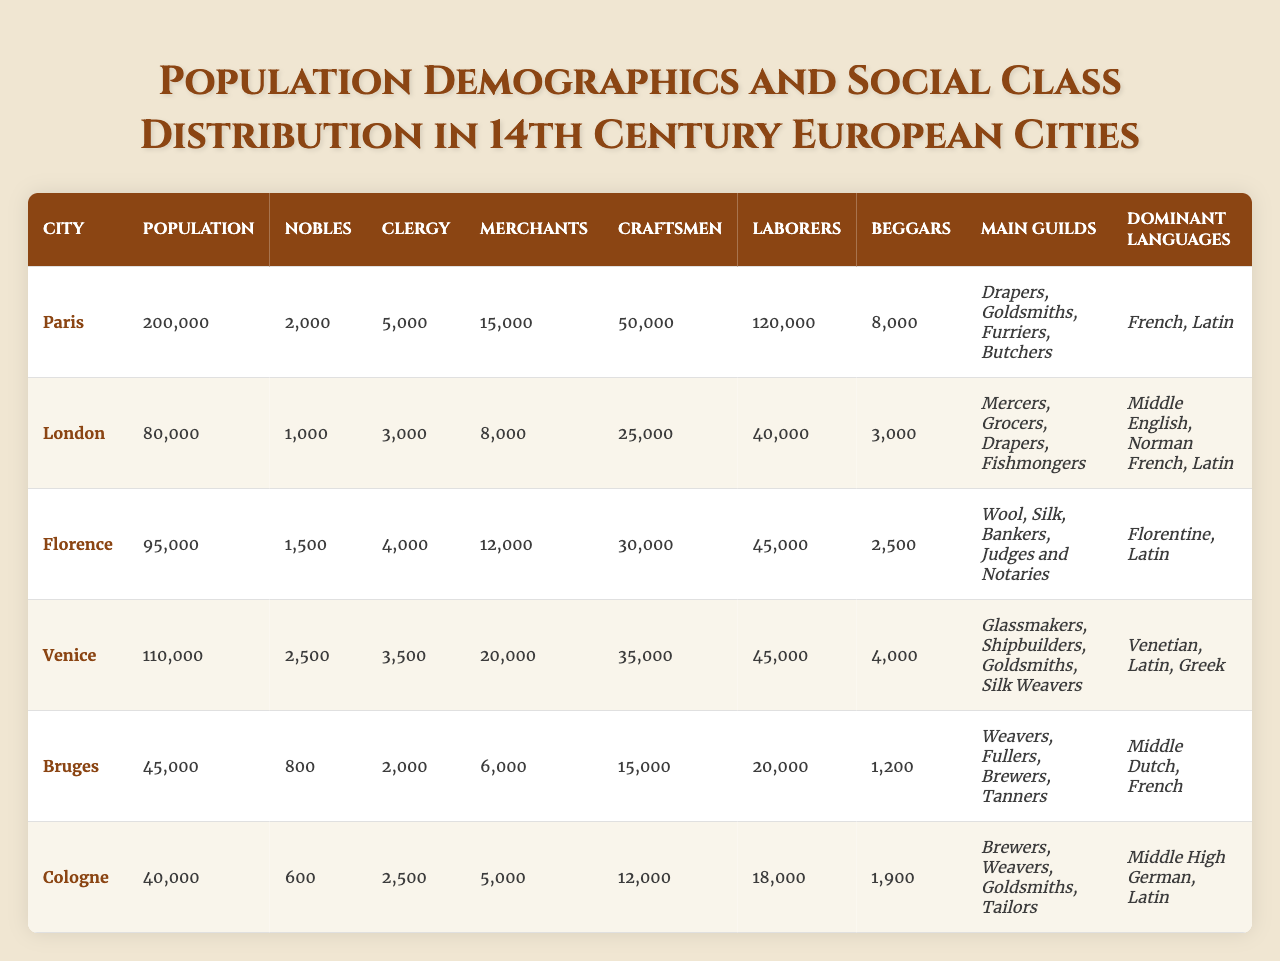What is the population of Venice? The table shows that the population of Venice is listed as 110,000.
Answer: 110,000 How many clergy are present in Paris? According to the data in the table, Paris has 5,000 clergy members.
Answer: 5,000 Which city has the highest number of laborers? The table indicates that Paris has 120,000 laborers, which is more than any other city listed.
Answer: Paris How many more beggars are there in London than in Bruges? London has 3,000 beggars and Bruges has 1,200. Subtracting these gives 3,000 - 1,200 = 1,800.
Answer: 1,800 What is the total number of nobles across all listed cities? The sum of nobles is calculated as: 2,000 (Paris) + 1,000 (London) + 1,500 (Florence) + 2,500 (Venice) + 800 (Bruges) + 600 (Cologne) = 8,400.
Answer: 8,400 Which city has the lowest population? By reviewing the population figures in the table, Cologne has the lowest population at 40,000.
Answer: Cologne Do more merchants live in London or Florence? London has 8,000 merchants while Florence has 12,000. Florence has more merchants, so it is confirmed by comparing these values.
Answer: Florence What percentage of the total population in Paris consists of laborers? The total population of Paris is 200,000, and there are 120,000 laborers. The percentage is (120,000 / 200,000) * 100 = 60%.
Answer: 60% Which city has the highest number of merchants? By looking at the merchant totals, Venice leads with 20,000 merchants; it's greater than the figures for the other cities.
Answer: Venice How do the total laborers compare between Cologne and Bruges? Cologne has 18,000 laborers while Bruges has 20,000. Therefore, 20,000 (Bruges) - 18,000 (Cologne) = 2,000, showing Bruges has more laborers by this amount.
Answer: Bruges has 2,000 more laborers 